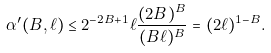Convert formula to latex. <formula><loc_0><loc_0><loc_500><loc_500>\alpha ^ { \prime } ( B , \ell ) \leq 2 ^ { - 2 B + 1 } \ell \frac { ( 2 B ) ^ { B } } { ( B \ell ) ^ { B } } = ( 2 \ell ) ^ { 1 - B } .</formula> 